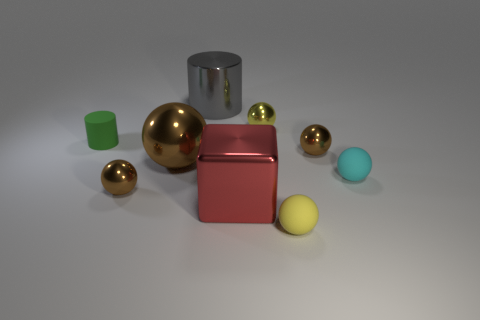What number of things are tiny spheres behind the green thing or shiny balls on the right side of the big gray thing?
Keep it short and to the point. 2. What shape is the rubber thing that is behind the tiny cyan thing?
Provide a succinct answer. Cylinder. Do the big red object that is behind the yellow rubber object and the tiny cyan rubber object have the same shape?
Your answer should be very brief. No. What number of objects are either tiny cyan spheres that are right of the small green rubber cylinder or green shiny cylinders?
Your answer should be very brief. 1. What is the color of the big metal object that is the same shape as the green matte object?
Provide a short and direct response. Gray. Is there anything else of the same color as the large ball?
Your response must be concise. Yes. What is the size of the yellow shiny ball behind the big ball?
Provide a short and direct response. Small. There is a metal cube; does it have the same color as the small thing behind the small cylinder?
Your answer should be compact. No. What number of other objects are there of the same material as the cyan sphere?
Give a very brief answer. 2. Is the number of large red things greater than the number of small blue matte blocks?
Your response must be concise. Yes. 